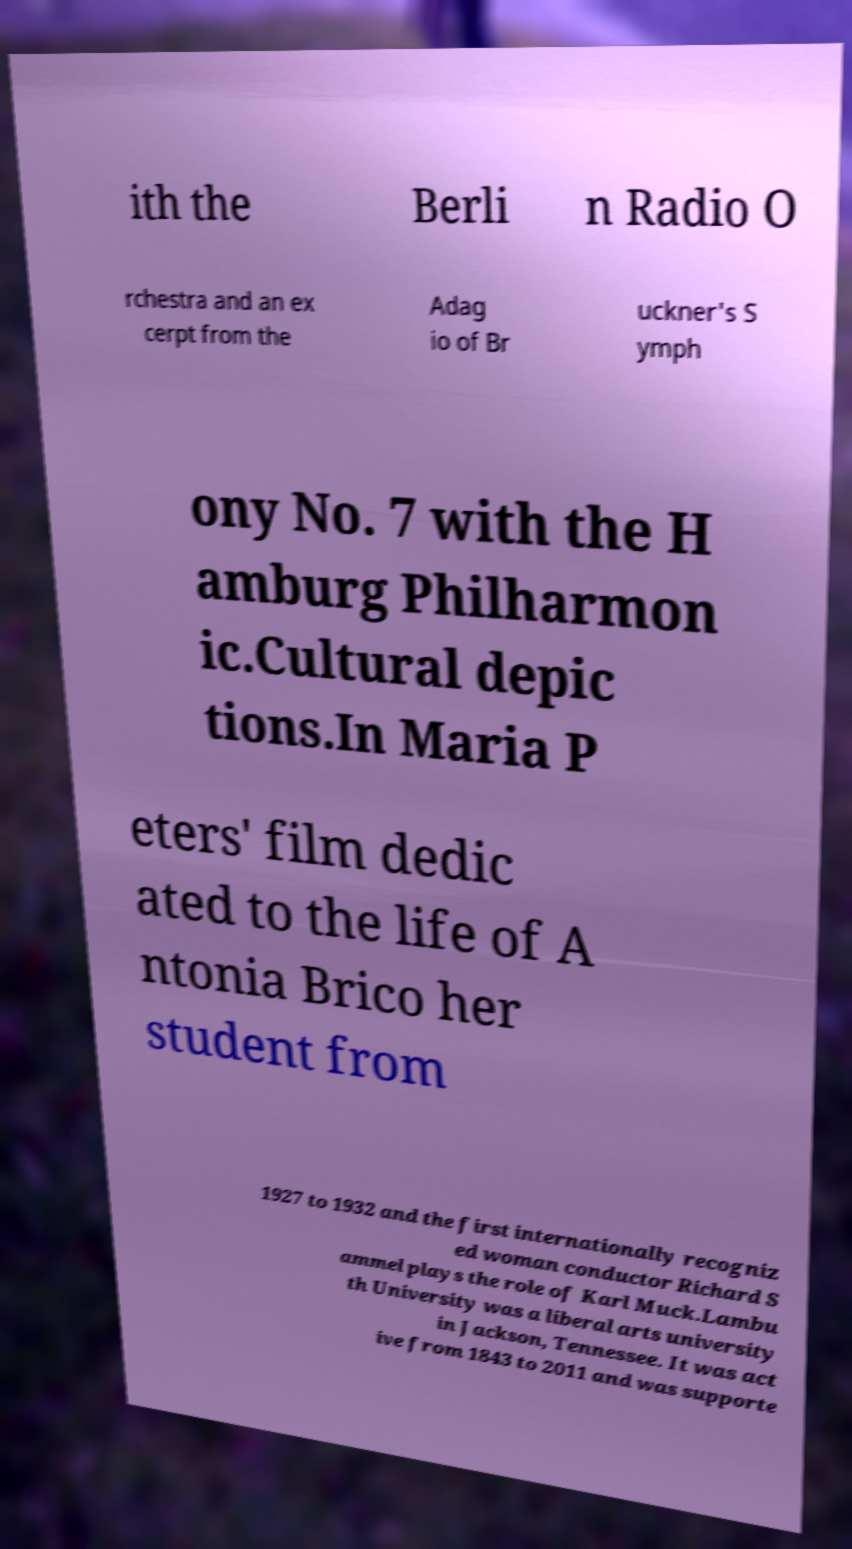Could you assist in decoding the text presented in this image and type it out clearly? ith the Berli n Radio O rchestra and an ex cerpt from the Adag io of Br uckner's S ymph ony No. 7 with the H amburg Philharmon ic.Cultural depic tions.In Maria P eters' film dedic ated to the life of A ntonia Brico her student from 1927 to 1932 and the first internationally recogniz ed woman conductor Richard S ammel plays the role of Karl Muck.Lambu th University was a liberal arts university in Jackson, Tennessee. It was act ive from 1843 to 2011 and was supporte 